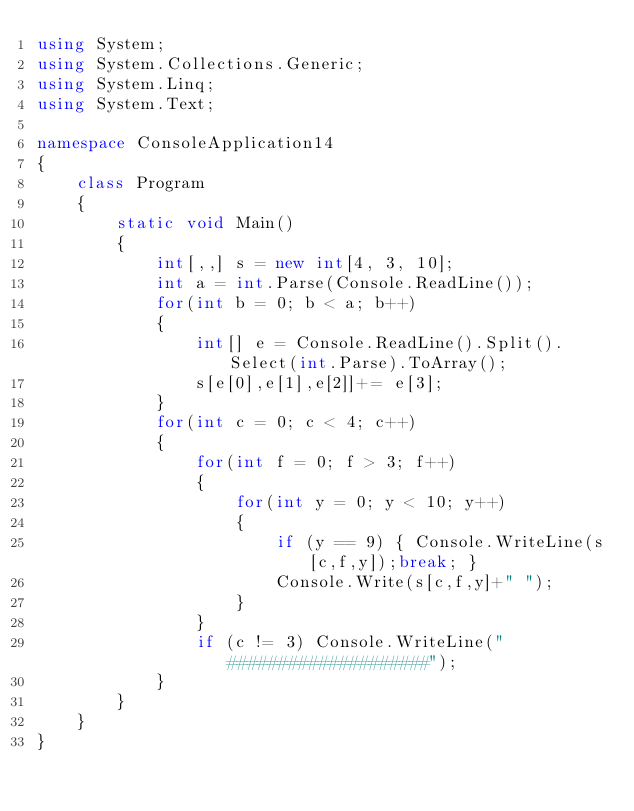<code> <loc_0><loc_0><loc_500><loc_500><_C#_>using System;
using System.Collections.Generic;
using System.Linq;
using System.Text;

namespace ConsoleApplication14
{
    class Program
    {
        static void Main()
        {
            int[,,] s = new int[4, 3, 10];
            int a = int.Parse(Console.ReadLine());
            for(int b = 0; b < a; b++)
            {
                int[] e = Console.ReadLine().Split().Select(int.Parse).ToArray();
                s[e[0],e[1],e[2]]+= e[3];
            }
            for(int c = 0; c < 4; c++)
            {
                for(int f = 0; f > 3; f++)
                {
                    for(int y = 0; y < 10; y++)
                    {
                        if (y == 9) { Console.WriteLine(s[c,f,y]);break; }
                        Console.Write(s[c,f,y]+" ");
                    }
                }
                if (c != 3) Console.WriteLine("####################");
            }
        }
    }
}</code> 